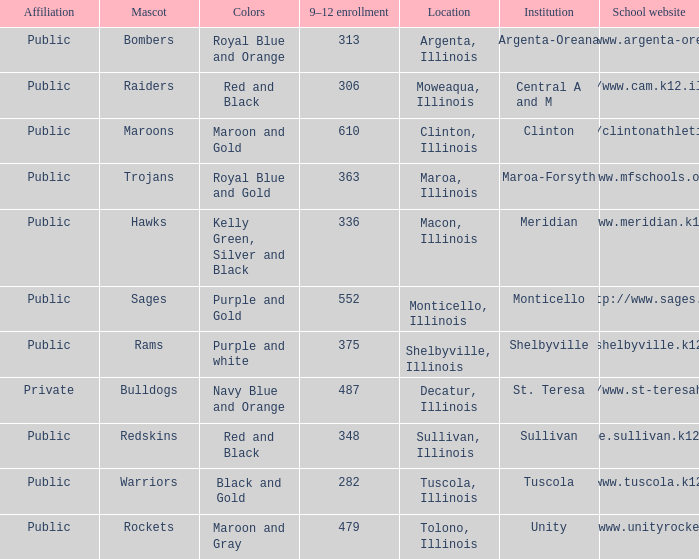What are the team colors from Tolono, Illinois? Maroon and Gray. I'm looking to parse the entire table for insights. Could you assist me with that? {'header': ['Affiliation', 'Mascot', 'Colors', '9–12 enrollment', 'Location', 'Institution', 'School website'], 'rows': [['Public', 'Bombers', 'Royal Blue and Orange', '313', 'Argenta, Illinois', 'Argenta-Oreana', 'http://www.argenta-oreana.org'], ['Public', 'Raiders', 'Red and Black', '306', 'Moweaqua, Illinois', 'Central A and M', 'http://www.cam.k12.il.us/hs'], ['Public', 'Maroons', 'Maroon and Gold', '610', 'Clinton, Illinois', 'Clinton', 'http://clintonathletics.com'], ['Public', 'Trojans', 'Royal Blue and Gold', '363', 'Maroa, Illinois', 'Maroa-Forsyth', 'http://www.mfschools.org/high/'], ['Public', 'Hawks', 'Kelly Green, Silver and Black', '336', 'Macon, Illinois', 'Meridian', 'http://www.meridian.k12.il.us/'], ['Public', 'Sages', 'Purple and Gold', '552', 'Monticello, Illinois', 'Monticello', 'http://www.sages.us'], ['Public', 'Rams', 'Purple and white', '375', 'Shelbyville, Illinois', 'Shelbyville', 'http://shelbyville.k12.il.us/'], ['Private', 'Bulldogs', 'Navy Blue and Orange', '487', 'Decatur, Illinois', 'St. Teresa', 'http://www.st-teresahs.org/'], ['Public', 'Redskins', 'Red and Black', '348', 'Sullivan, Illinois', 'Sullivan', 'http://home.sullivan.k12.il.us/shs'], ['Public', 'Warriors', 'Black and Gold', '282', 'Tuscola, Illinois', 'Tuscola', 'http://www.tuscola.k12.il.us/'], ['Public', 'Rockets', 'Maroon and Gray', '479', 'Tolono, Illinois', 'Unity', 'http://www.unityrockets.com/']]} 